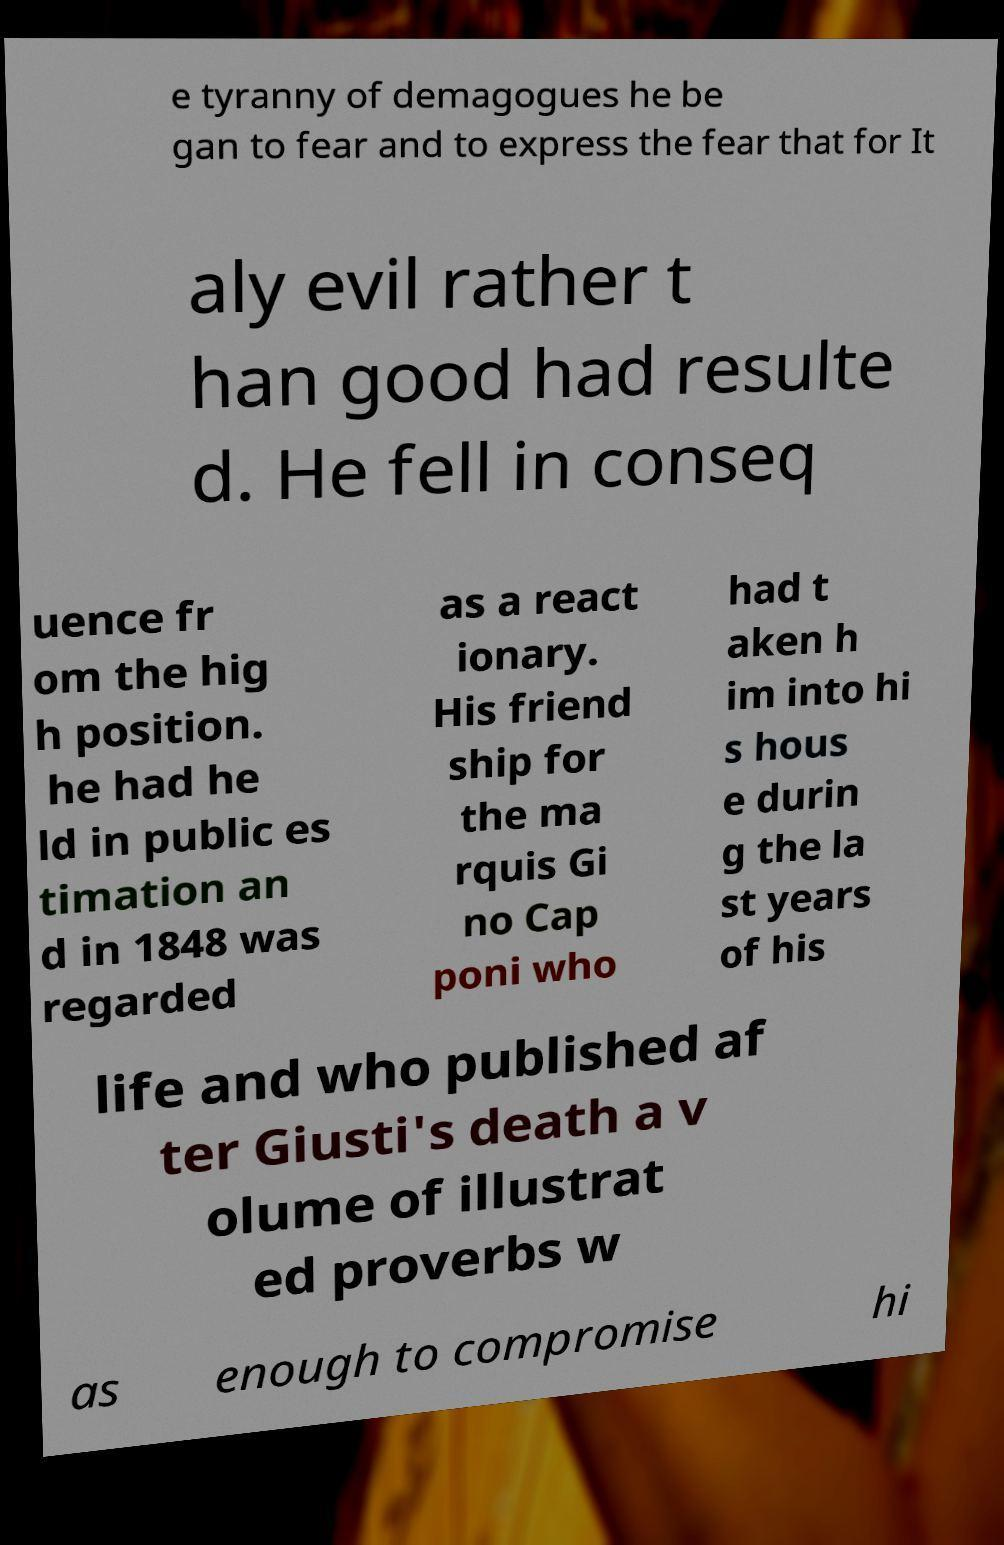Can you accurately transcribe the text from the provided image for me? e tyranny of demagogues he be gan to fear and to express the fear that for It aly evil rather t han good had resulte d. He fell in conseq uence fr om the hig h position. he had he ld in public es timation an d in 1848 was regarded as a react ionary. His friend ship for the ma rquis Gi no Cap poni who had t aken h im into hi s hous e durin g the la st years of his life and who published af ter Giusti's death a v olume of illustrat ed proverbs w as enough to compromise hi 